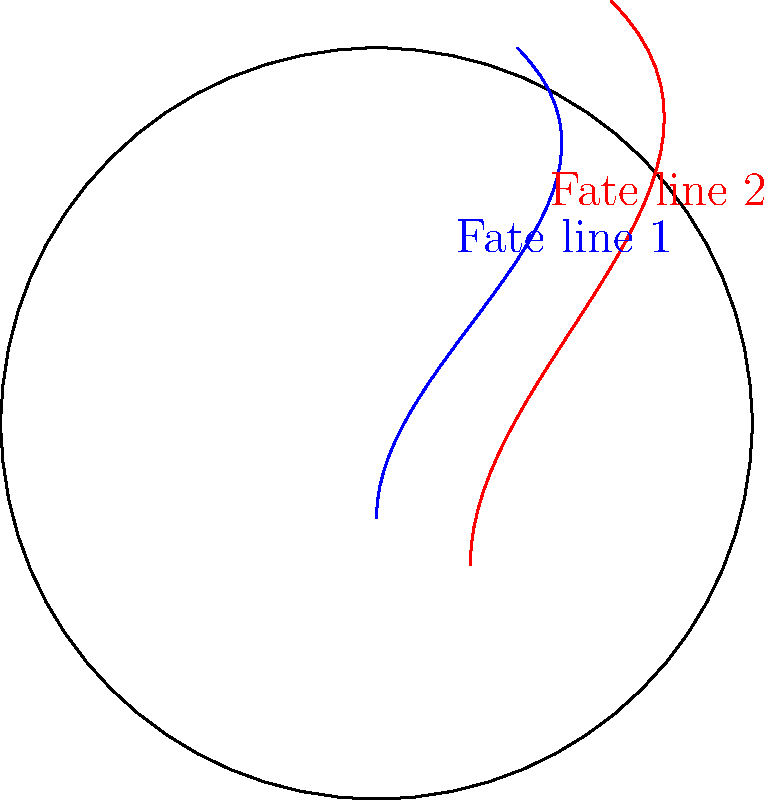In this simplified palm sketch, two fate lines are drawn: one in blue and one in red. If the blue fate line is $\pi$ cm long, what is the length of the red fate line to the nearest 0.1 cm, assuming the palm outline is a perfect circle with a diameter of 10 cm? To solve this problem, let's follow these steps:

1) First, we need to understand the scale of the diagram. The palm outline is a circle with a diameter of 10 cm.

2) The blue fate line is given to be $\pi$ cm long. This will be our reference for measuring the red fate line.

3) To compare the lengths, we can use the arclength formula: $L = r\theta$, where $L$ is the length of the arc, $r$ is the radius, and $\theta$ is the central angle in radians.

4) For the blue line:
   $\pi = 5\theta_1$  (since the radius is 5 cm)
   $\theta_1 = \frac{\pi}{5}$ radians

5) Now, we need to estimate the central angle for the red line. It appears to be about 1.2 times the angle of the blue line.
   $\theta_2 \approx 1.2 \times \frac{\pi}{5} = \frac{6\pi}{25}$ radians

6) Using this angle, we can calculate the length of the red line:
   $L_2 = 5 \times \frac{6\pi}{25} = \frac{6\pi}{5} \approx 3.77$ cm

7) Rounding to the nearest 0.1 cm, we get 3.8 cm.
Answer: 3.8 cm 